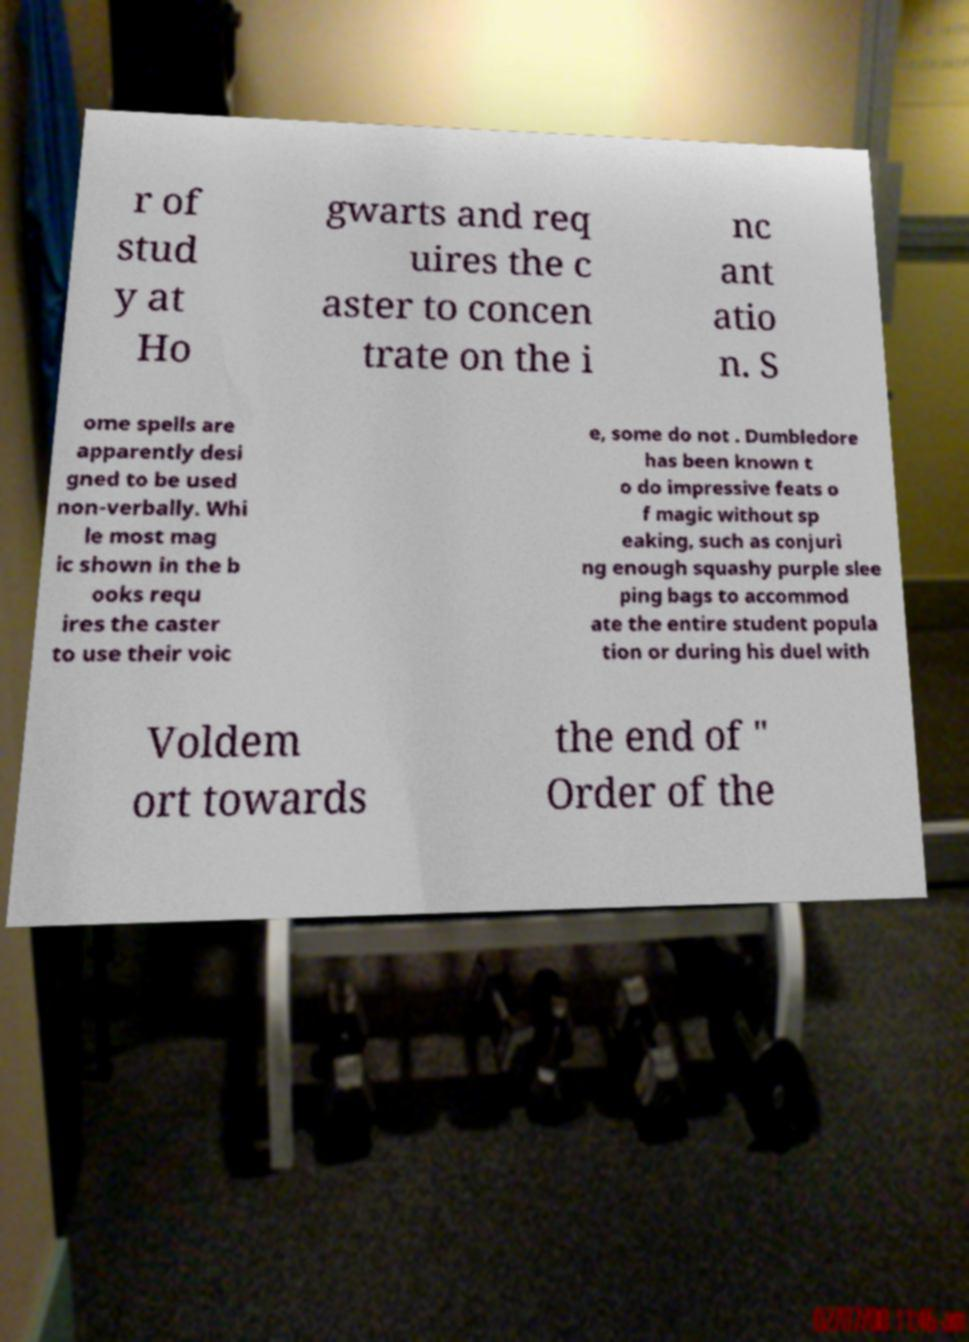Can you accurately transcribe the text from the provided image for me? r of stud y at Ho gwarts and req uires the c aster to concen trate on the i nc ant atio n. S ome spells are apparently desi gned to be used non-verbally. Whi le most mag ic shown in the b ooks requ ires the caster to use their voic e, some do not . Dumbledore has been known t o do impressive feats o f magic without sp eaking, such as conjuri ng enough squashy purple slee ping bags to accommod ate the entire student popula tion or during his duel with Voldem ort towards the end of " Order of the 